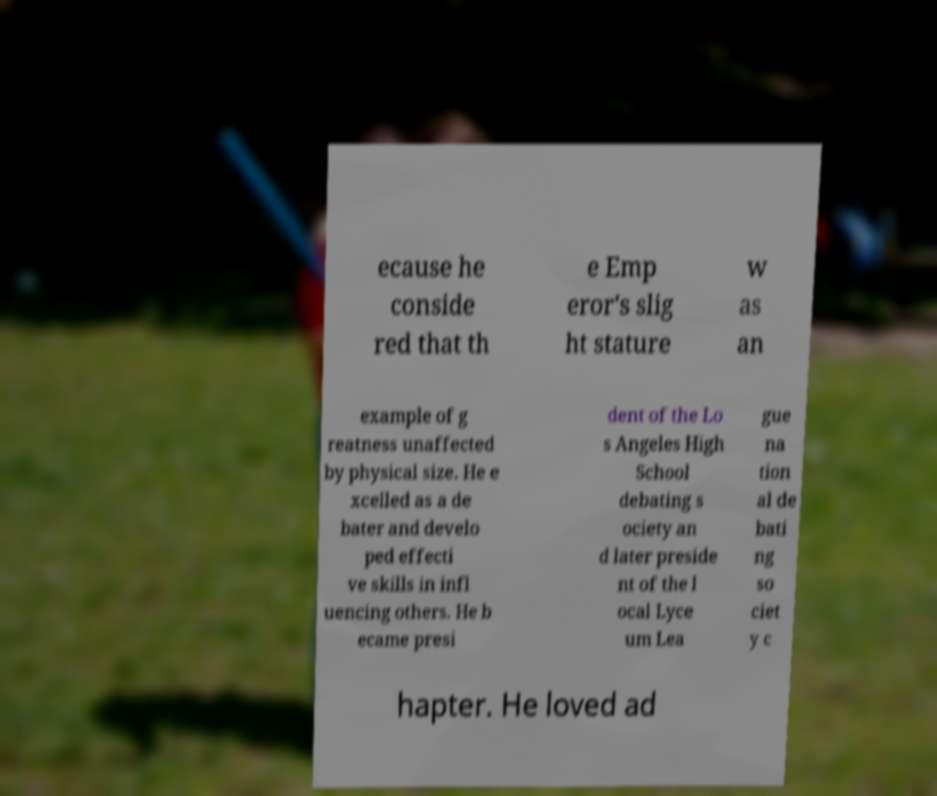Please read and relay the text visible in this image. What does it say? ecause he conside red that th e Emp eror's slig ht stature w as an example of g reatness unaffected by physical size. He e xcelled as a de bater and develo ped effecti ve skills in infl uencing others. He b ecame presi dent of the Lo s Angeles High School debating s ociety an d later preside nt of the l ocal Lyce um Lea gue na tion al de bati ng so ciet y c hapter. He loved ad 